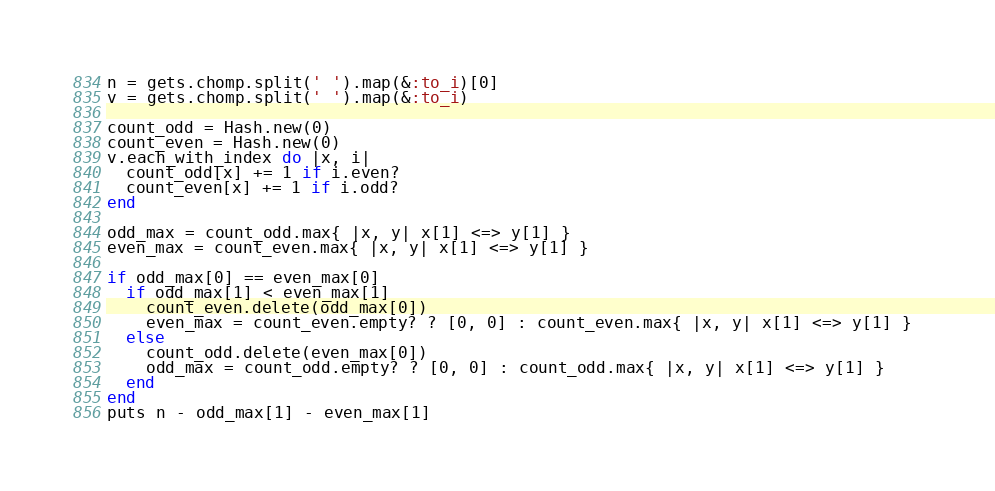Convert code to text. <code><loc_0><loc_0><loc_500><loc_500><_Ruby_>n = gets.chomp.split(' ').map(&:to_i)[0]
v = gets.chomp.split(' ').map(&:to_i)

count_odd = Hash.new(0)
count_even = Hash.new(0)
v.each_with_index do |x, i|
  count_odd[x] += 1 if i.even?
  count_even[x] += 1 if i.odd?
end

odd_max = count_odd.max{ |x, y| x[1] <=> y[1] } 
even_max = count_even.max{ |x, y| x[1] <=> y[1] } 

if odd_max[0] == even_max[0]
  if odd_max[1] < even_max[1]
    count_even.delete(odd_max[0])
    even_max = count_even.empty? ? [0, 0] : count_even.max{ |x, y| x[1] <=> y[1] } 
  else
    count_odd.delete(even_max[0])
    odd_max = count_odd.empty? ? [0, 0] : count_odd.max{ |x, y| x[1] <=> y[1] } 
  end
end
puts n - odd_max[1] - even_max[1]</code> 